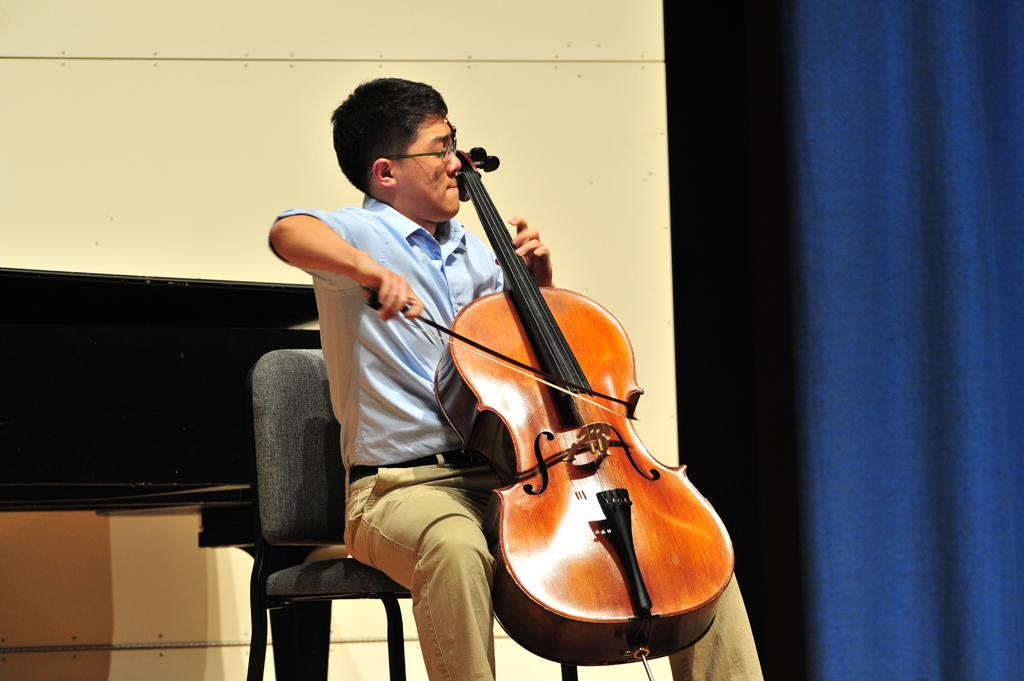What is the man in the image doing? The man is sitting in the middle of the image and playing a violin. What can be seen on the right side of the image? There is a curtain on the right side of the image. What is visible in the top left side of the image? There is a wall visible in the top left side of the image. What type of flower is on the table in the image? There is no flower present in the image. 